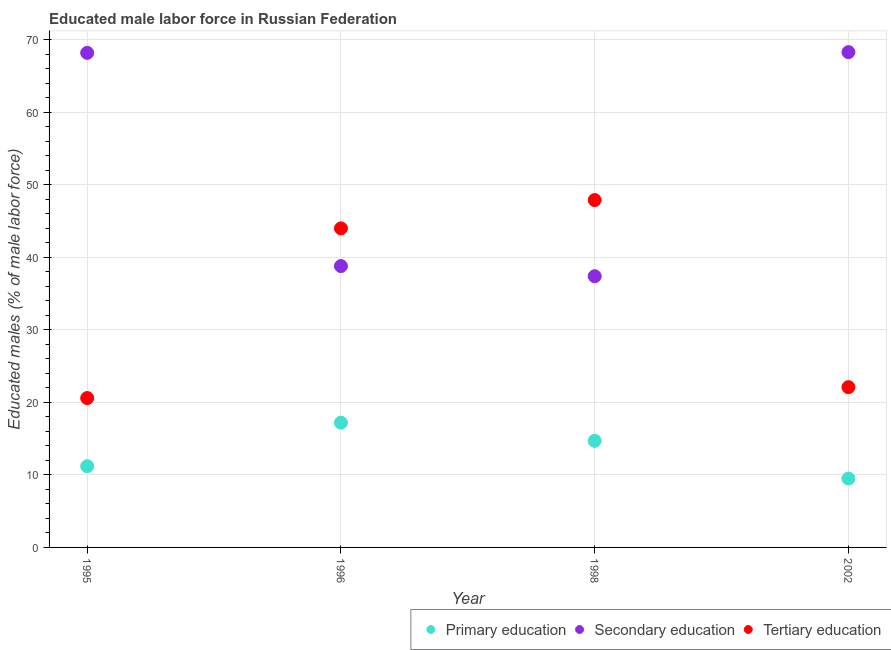How many different coloured dotlines are there?
Make the answer very short. 3. What is the percentage of male labor force who received tertiary education in 2002?
Give a very brief answer. 22.1. Across all years, what is the maximum percentage of male labor force who received secondary education?
Your answer should be very brief. 68.3. Across all years, what is the minimum percentage of male labor force who received primary education?
Give a very brief answer. 9.5. In which year was the percentage of male labor force who received tertiary education maximum?
Offer a very short reply. 1998. What is the total percentage of male labor force who received tertiary education in the graph?
Offer a terse response. 134.6. What is the difference between the percentage of male labor force who received secondary education in 1995 and that in 2002?
Offer a very short reply. -0.1. What is the difference between the percentage of male labor force who received primary education in 2002 and the percentage of male labor force who received secondary education in 1996?
Provide a short and direct response. -29.3. What is the average percentage of male labor force who received secondary education per year?
Make the answer very short. 53.18. In the year 1995, what is the difference between the percentage of male labor force who received tertiary education and percentage of male labor force who received primary education?
Keep it short and to the point. 9.4. What is the ratio of the percentage of male labor force who received tertiary education in 1995 to that in 1998?
Offer a very short reply. 0.43. Is the percentage of male labor force who received secondary education in 1995 less than that in 1998?
Offer a terse response. No. What is the difference between the highest and the second highest percentage of male labor force who received tertiary education?
Provide a short and direct response. 3.9. What is the difference between the highest and the lowest percentage of male labor force who received secondary education?
Make the answer very short. 30.9. Is it the case that in every year, the sum of the percentage of male labor force who received primary education and percentage of male labor force who received secondary education is greater than the percentage of male labor force who received tertiary education?
Provide a short and direct response. Yes. Is the percentage of male labor force who received secondary education strictly greater than the percentage of male labor force who received tertiary education over the years?
Your response must be concise. No. Is the percentage of male labor force who received tertiary education strictly less than the percentage of male labor force who received primary education over the years?
Offer a very short reply. No. How many dotlines are there?
Your answer should be compact. 3. How many years are there in the graph?
Offer a terse response. 4. Does the graph contain grids?
Your response must be concise. Yes. How are the legend labels stacked?
Keep it short and to the point. Horizontal. What is the title of the graph?
Your response must be concise. Educated male labor force in Russian Federation. Does "Social Insurance" appear as one of the legend labels in the graph?
Provide a short and direct response. No. What is the label or title of the X-axis?
Make the answer very short. Year. What is the label or title of the Y-axis?
Your answer should be very brief. Educated males (% of male labor force). What is the Educated males (% of male labor force) in Primary education in 1995?
Offer a very short reply. 11.2. What is the Educated males (% of male labor force) of Secondary education in 1995?
Ensure brevity in your answer.  68.2. What is the Educated males (% of male labor force) of Tertiary education in 1995?
Your answer should be very brief. 20.6. What is the Educated males (% of male labor force) in Primary education in 1996?
Your response must be concise. 17.2. What is the Educated males (% of male labor force) of Secondary education in 1996?
Provide a short and direct response. 38.8. What is the Educated males (% of male labor force) of Tertiary education in 1996?
Provide a succinct answer. 44. What is the Educated males (% of male labor force) in Primary education in 1998?
Your answer should be compact. 14.7. What is the Educated males (% of male labor force) in Secondary education in 1998?
Make the answer very short. 37.4. What is the Educated males (% of male labor force) in Tertiary education in 1998?
Give a very brief answer. 47.9. What is the Educated males (% of male labor force) in Primary education in 2002?
Your response must be concise. 9.5. What is the Educated males (% of male labor force) of Secondary education in 2002?
Your answer should be very brief. 68.3. What is the Educated males (% of male labor force) in Tertiary education in 2002?
Give a very brief answer. 22.1. Across all years, what is the maximum Educated males (% of male labor force) in Primary education?
Provide a succinct answer. 17.2. Across all years, what is the maximum Educated males (% of male labor force) in Secondary education?
Your answer should be very brief. 68.3. Across all years, what is the maximum Educated males (% of male labor force) in Tertiary education?
Keep it short and to the point. 47.9. Across all years, what is the minimum Educated males (% of male labor force) in Secondary education?
Give a very brief answer. 37.4. Across all years, what is the minimum Educated males (% of male labor force) of Tertiary education?
Give a very brief answer. 20.6. What is the total Educated males (% of male labor force) in Primary education in the graph?
Your response must be concise. 52.6. What is the total Educated males (% of male labor force) of Secondary education in the graph?
Ensure brevity in your answer.  212.7. What is the total Educated males (% of male labor force) in Tertiary education in the graph?
Your answer should be very brief. 134.6. What is the difference between the Educated males (% of male labor force) of Primary education in 1995 and that in 1996?
Offer a very short reply. -6. What is the difference between the Educated males (% of male labor force) of Secondary education in 1995 and that in 1996?
Your response must be concise. 29.4. What is the difference between the Educated males (% of male labor force) in Tertiary education in 1995 and that in 1996?
Keep it short and to the point. -23.4. What is the difference between the Educated males (% of male labor force) in Primary education in 1995 and that in 1998?
Your answer should be compact. -3.5. What is the difference between the Educated males (% of male labor force) of Secondary education in 1995 and that in 1998?
Your answer should be compact. 30.8. What is the difference between the Educated males (% of male labor force) of Tertiary education in 1995 and that in 1998?
Keep it short and to the point. -27.3. What is the difference between the Educated males (% of male labor force) of Tertiary education in 1995 and that in 2002?
Ensure brevity in your answer.  -1.5. What is the difference between the Educated males (% of male labor force) of Primary education in 1996 and that in 1998?
Your answer should be compact. 2.5. What is the difference between the Educated males (% of male labor force) of Secondary education in 1996 and that in 1998?
Your answer should be compact. 1.4. What is the difference between the Educated males (% of male labor force) in Tertiary education in 1996 and that in 1998?
Your response must be concise. -3.9. What is the difference between the Educated males (% of male labor force) of Primary education in 1996 and that in 2002?
Provide a short and direct response. 7.7. What is the difference between the Educated males (% of male labor force) of Secondary education in 1996 and that in 2002?
Provide a succinct answer. -29.5. What is the difference between the Educated males (% of male labor force) in Tertiary education in 1996 and that in 2002?
Provide a succinct answer. 21.9. What is the difference between the Educated males (% of male labor force) of Secondary education in 1998 and that in 2002?
Make the answer very short. -30.9. What is the difference between the Educated males (% of male labor force) of Tertiary education in 1998 and that in 2002?
Offer a terse response. 25.8. What is the difference between the Educated males (% of male labor force) of Primary education in 1995 and the Educated males (% of male labor force) of Secondary education in 1996?
Ensure brevity in your answer.  -27.6. What is the difference between the Educated males (% of male labor force) in Primary education in 1995 and the Educated males (% of male labor force) in Tertiary education in 1996?
Give a very brief answer. -32.8. What is the difference between the Educated males (% of male labor force) of Secondary education in 1995 and the Educated males (% of male labor force) of Tertiary education in 1996?
Ensure brevity in your answer.  24.2. What is the difference between the Educated males (% of male labor force) in Primary education in 1995 and the Educated males (% of male labor force) in Secondary education in 1998?
Give a very brief answer. -26.2. What is the difference between the Educated males (% of male labor force) in Primary education in 1995 and the Educated males (% of male labor force) in Tertiary education in 1998?
Ensure brevity in your answer.  -36.7. What is the difference between the Educated males (% of male labor force) of Secondary education in 1995 and the Educated males (% of male labor force) of Tertiary education in 1998?
Your answer should be compact. 20.3. What is the difference between the Educated males (% of male labor force) in Primary education in 1995 and the Educated males (% of male labor force) in Secondary education in 2002?
Offer a terse response. -57.1. What is the difference between the Educated males (% of male labor force) in Secondary education in 1995 and the Educated males (% of male labor force) in Tertiary education in 2002?
Offer a very short reply. 46.1. What is the difference between the Educated males (% of male labor force) in Primary education in 1996 and the Educated males (% of male labor force) in Secondary education in 1998?
Offer a terse response. -20.2. What is the difference between the Educated males (% of male labor force) in Primary education in 1996 and the Educated males (% of male labor force) in Tertiary education in 1998?
Your response must be concise. -30.7. What is the difference between the Educated males (% of male labor force) in Primary education in 1996 and the Educated males (% of male labor force) in Secondary education in 2002?
Offer a terse response. -51.1. What is the difference between the Educated males (% of male labor force) in Primary education in 1996 and the Educated males (% of male labor force) in Tertiary education in 2002?
Provide a succinct answer. -4.9. What is the difference between the Educated males (% of male labor force) of Primary education in 1998 and the Educated males (% of male labor force) of Secondary education in 2002?
Provide a succinct answer. -53.6. What is the average Educated males (% of male labor force) of Primary education per year?
Your answer should be very brief. 13.15. What is the average Educated males (% of male labor force) in Secondary education per year?
Make the answer very short. 53.17. What is the average Educated males (% of male labor force) of Tertiary education per year?
Give a very brief answer. 33.65. In the year 1995, what is the difference between the Educated males (% of male labor force) in Primary education and Educated males (% of male labor force) in Secondary education?
Make the answer very short. -57. In the year 1995, what is the difference between the Educated males (% of male labor force) of Primary education and Educated males (% of male labor force) of Tertiary education?
Provide a short and direct response. -9.4. In the year 1995, what is the difference between the Educated males (% of male labor force) in Secondary education and Educated males (% of male labor force) in Tertiary education?
Provide a succinct answer. 47.6. In the year 1996, what is the difference between the Educated males (% of male labor force) in Primary education and Educated males (% of male labor force) in Secondary education?
Ensure brevity in your answer.  -21.6. In the year 1996, what is the difference between the Educated males (% of male labor force) in Primary education and Educated males (% of male labor force) in Tertiary education?
Offer a terse response. -26.8. In the year 1996, what is the difference between the Educated males (% of male labor force) in Secondary education and Educated males (% of male labor force) in Tertiary education?
Keep it short and to the point. -5.2. In the year 1998, what is the difference between the Educated males (% of male labor force) of Primary education and Educated males (% of male labor force) of Secondary education?
Keep it short and to the point. -22.7. In the year 1998, what is the difference between the Educated males (% of male labor force) in Primary education and Educated males (% of male labor force) in Tertiary education?
Your answer should be very brief. -33.2. In the year 1998, what is the difference between the Educated males (% of male labor force) in Secondary education and Educated males (% of male labor force) in Tertiary education?
Keep it short and to the point. -10.5. In the year 2002, what is the difference between the Educated males (% of male labor force) of Primary education and Educated males (% of male labor force) of Secondary education?
Your answer should be compact. -58.8. In the year 2002, what is the difference between the Educated males (% of male labor force) in Primary education and Educated males (% of male labor force) in Tertiary education?
Offer a very short reply. -12.6. In the year 2002, what is the difference between the Educated males (% of male labor force) in Secondary education and Educated males (% of male labor force) in Tertiary education?
Make the answer very short. 46.2. What is the ratio of the Educated males (% of male labor force) of Primary education in 1995 to that in 1996?
Make the answer very short. 0.65. What is the ratio of the Educated males (% of male labor force) of Secondary education in 1995 to that in 1996?
Give a very brief answer. 1.76. What is the ratio of the Educated males (% of male labor force) of Tertiary education in 1995 to that in 1996?
Provide a short and direct response. 0.47. What is the ratio of the Educated males (% of male labor force) in Primary education in 1995 to that in 1998?
Make the answer very short. 0.76. What is the ratio of the Educated males (% of male labor force) of Secondary education in 1995 to that in 1998?
Offer a terse response. 1.82. What is the ratio of the Educated males (% of male labor force) of Tertiary education in 1995 to that in 1998?
Ensure brevity in your answer.  0.43. What is the ratio of the Educated males (% of male labor force) of Primary education in 1995 to that in 2002?
Offer a very short reply. 1.18. What is the ratio of the Educated males (% of male labor force) in Tertiary education in 1995 to that in 2002?
Keep it short and to the point. 0.93. What is the ratio of the Educated males (% of male labor force) of Primary education in 1996 to that in 1998?
Give a very brief answer. 1.17. What is the ratio of the Educated males (% of male labor force) of Secondary education in 1996 to that in 1998?
Ensure brevity in your answer.  1.04. What is the ratio of the Educated males (% of male labor force) in Tertiary education in 1996 to that in 1998?
Your answer should be very brief. 0.92. What is the ratio of the Educated males (% of male labor force) in Primary education in 1996 to that in 2002?
Offer a terse response. 1.81. What is the ratio of the Educated males (% of male labor force) of Secondary education in 1996 to that in 2002?
Offer a terse response. 0.57. What is the ratio of the Educated males (% of male labor force) in Tertiary education in 1996 to that in 2002?
Give a very brief answer. 1.99. What is the ratio of the Educated males (% of male labor force) in Primary education in 1998 to that in 2002?
Your response must be concise. 1.55. What is the ratio of the Educated males (% of male labor force) of Secondary education in 1998 to that in 2002?
Offer a very short reply. 0.55. What is the ratio of the Educated males (% of male labor force) in Tertiary education in 1998 to that in 2002?
Your answer should be compact. 2.17. What is the difference between the highest and the second highest Educated males (% of male labor force) of Secondary education?
Keep it short and to the point. 0.1. What is the difference between the highest and the lowest Educated males (% of male labor force) of Secondary education?
Your answer should be very brief. 30.9. What is the difference between the highest and the lowest Educated males (% of male labor force) of Tertiary education?
Ensure brevity in your answer.  27.3. 